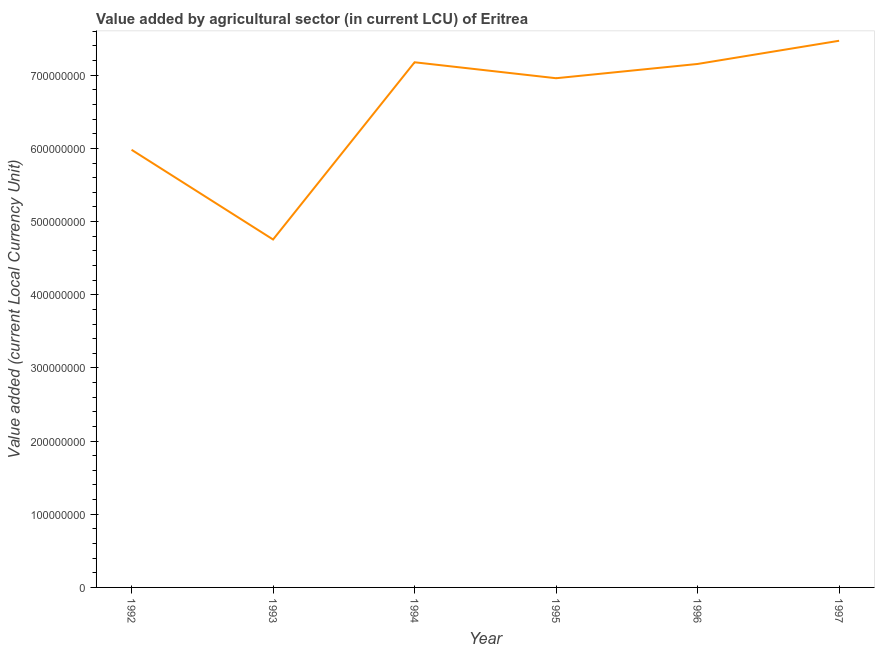What is the value added by agriculture sector in 1992?
Ensure brevity in your answer.  5.98e+08. Across all years, what is the maximum value added by agriculture sector?
Offer a very short reply. 7.47e+08. Across all years, what is the minimum value added by agriculture sector?
Your answer should be compact. 4.76e+08. What is the sum of the value added by agriculture sector?
Give a very brief answer. 3.95e+09. What is the difference between the value added by agriculture sector in 1994 and 1996?
Provide a short and direct response. 2.30e+06. What is the average value added by agriculture sector per year?
Ensure brevity in your answer.  6.58e+08. What is the median value added by agriculture sector?
Give a very brief answer. 7.06e+08. What is the ratio of the value added by agriculture sector in 1992 to that in 1996?
Keep it short and to the point. 0.84. Is the value added by agriculture sector in 1992 less than that in 1994?
Your answer should be compact. Yes. What is the difference between the highest and the second highest value added by agriculture sector?
Your answer should be very brief. 2.94e+07. What is the difference between the highest and the lowest value added by agriculture sector?
Offer a very short reply. 2.72e+08. What is the difference between two consecutive major ticks on the Y-axis?
Ensure brevity in your answer.  1.00e+08. Does the graph contain any zero values?
Give a very brief answer. No. What is the title of the graph?
Your answer should be very brief. Value added by agricultural sector (in current LCU) of Eritrea. What is the label or title of the X-axis?
Give a very brief answer. Year. What is the label or title of the Y-axis?
Your answer should be very brief. Value added (current Local Currency Unit). What is the Value added (current Local Currency Unit) in 1992?
Give a very brief answer. 5.98e+08. What is the Value added (current Local Currency Unit) of 1993?
Give a very brief answer. 4.76e+08. What is the Value added (current Local Currency Unit) in 1994?
Ensure brevity in your answer.  7.18e+08. What is the Value added (current Local Currency Unit) in 1995?
Ensure brevity in your answer.  6.96e+08. What is the Value added (current Local Currency Unit) of 1996?
Keep it short and to the point. 7.15e+08. What is the Value added (current Local Currency Unit) in 1997?
Give a very brief answer. 7.47e+08. What is the difference between the Value added (current Local Currency Unit) in 1992 and 1993?
Offer a very short reply. 1.23e+08. What is the difference between the Value added (current Local Currency Unit) in 1992 and 1994?
Offer a terse response. -1.20e+08. What is the difference between the Value added (current Local Currency Unit) in 1992 and 1995?
Give a very brief answer. -9.78e+07. What is the difference between the Value added (current Local Currency Unit) in 1992 and 1996?
Provide a short and direct response. -1.17e+08. What is the difference between the Value added (current Local Currency Unit) in 1992 and 1997?
Provide a short and direct response. -1.49e+08. What is the difference between the Value added (current Local Currency Unit) in 1993 and 1994?
Provide a succinct answer. -2.42e+08. What is the difference between the Value added (current Local Currency Unit) in 1993 and 1995?
Keep it short and to the point. -2.20e+08. What is the difference between the Value added (current Local Currency Unit) in 1993 and 1996?
Ensure brevity in your answer.  -2.40e+08. What is the difference between the Value added (current Local Currency Unit) in 1993 and 1997?
Your response must be concise. -2.72e+08. What is the difference between the Value added (current Local Currency Unit) in 1994 and 1995?
Your answer should be very brief. 2.18e+07. What is the difference between the Value added (current Local Currency Unit) in 1994 and 1996?
Provide a short and direct response. 2.30e+06. What is the difference between the Value added (current Local Currency Unit) in 1994 and 1997?
Give a very brief answer. -2.94e+07. What is the difference between the Value added (current Local Currency Unit) in 1995 and 1996?
Give a very brief answer. -1.95e+07. What is the difference between the Value added (current Local Currency Unit) in 1995 and 1997?
Make the answer very short. -5.12e+07. What is the difference between the Value added (current Local Currency Unit) in 1996 and 1997?
Provide a succinct answer. -3.17e+07. What is the ratio of the Value added (current Local Currency Unit) in 1992 to that in 1993?
Your answer should be very brief. 1.26. What is the ratio of the Value added (current Local Currency Unit) in 1992 to that in 1994?
Provide a short and direct response. 0.83. What is the ratio of the Value added (current Local Currency Unit) in 1992 to that in 1995?
Make the answer very short. 0.86. What is the ratio of the Value added (current Local Currency Unit) in 1992 to that in 1996?
Provide a succinct answer. 0.84. What is the ratio of the Value added (current Local Currency Unit) in 1992 to that in 1997?
Offer a terse response. 0.8. What is the ratio of the Value added (current Local Currency Unit) in 1993 to that in 1994?
Your answer should be compact. 0.66. What is the ratio of the Value added (current Local Currency Unit) in 1993 to that in 1995?
Your answer should be very brief. 0.68. What is the ratio of the Value added (current Local Currency Unit) in 1993 to that in 1996?
Keep it short and to the point. 0.67. What is the ratio of the Value added (current Local Currency Unit) in 1993 to that in 1997?
Make the answer very short. 0.64. What is the ratio of the Value added (current Local Currency Unit) in 1994 to that in 1995?
Keep it short and to the point. 1.03. What is the ratio of the Value added (current Local Currency Unit) in 1995 to that in 1997?
Give a very brief answer. 0.93. What is the ratio of the Value added (current Local Currency Unit) in 1996 to that in 1997?
Ensure brevity in your answer.  0.96. 